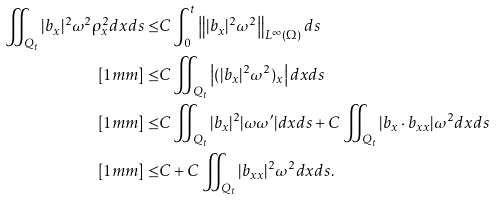Convert formula to latex. <formula><loc_0><loc_0><loc_500><loc_500>\iint _ { Q _ { t } } | b _ { x } | ^ { 2 } \omega ^ { 2 } \rho _ { x } ^ { 2 } d x d s \leq & C \int _ { 0 } ^ { t } \left \| | b _ { x } | ^ { 2 } \omega ^ { 2 } \right \| _ { L ^ { \infty } ( \Omega ) } d s \\ [ 1 m m ] \leq & C \iint _ { Q _ { t } } \left | ( | b _ { x } | ^ { 2 } \omega ^ { 2 } ) _ { x } \right | d x d s \\ [ 1 m m ] \leq & C \iint _ { Q _ { t } } | b _ { x } | ^ { 2 } | \omega \omega ^ { \prime } | d x d s + C \iint _ { Q _ { t } } | b _ { x } \cdot b _ { x x } | \omega ^ { 2 } d x d s \\ [ 1 m m ] \leq & C + C \iint _ { Q _ { t } } | b _ { x x } | ^ { 2 } \omega ^ { 2 } d x d s .</formula> 